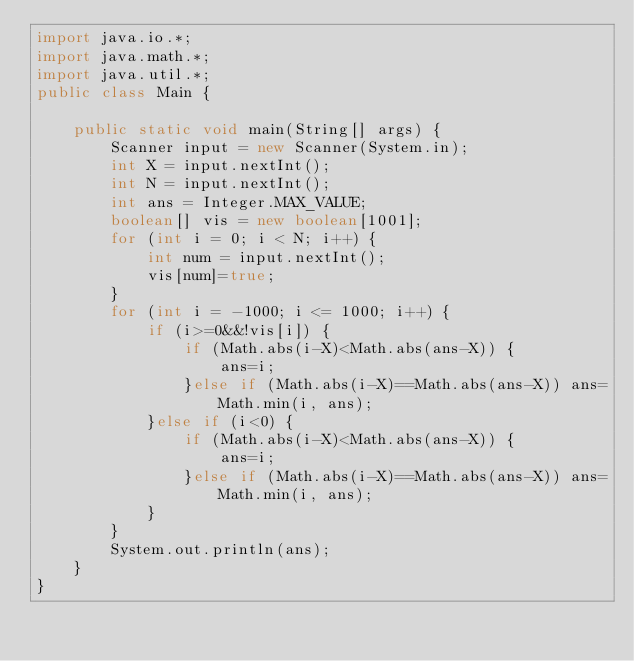<code> <loc_0><loc_0><loc_500><loc_500><_Java_>import java.io.*;
import java.math.*;
import java.util.*;
public class Main { 

	public static void main(String[] args) { 
		Scanner input = new Scanner(System.in); 
		int X = input.nextInt();
		int N = input.nextInt();
		int ans = Integer.MAX_VALUE;
		boolean[] vis = new boolean[1001];
		for (int i = 0; i < N; i++) {
			int num = input.nextInt();
			vis[num]=true;
		}
		for (int i = -1000; i <= 1000; i++) {
			if (i>=0&&!vis[i]) {
				if (Math.abs(i-X)<Math.abs(ans-X)) {
					ans=i;
				}else if (Math.abs(i-X)==Math.abs(ans-X)) ans=Math.min(i, ans);
			}else if (i<0) {
				if (Math.abs(i-X)<Math.abs(ans-X)) {
					ans=i;
				}else if (Math.abs(i-X)==Math.abs(ans-X)) ans=Math.min(i, ans);
			}
		}
		System.out.println(ans);
	}	
}
</code> 